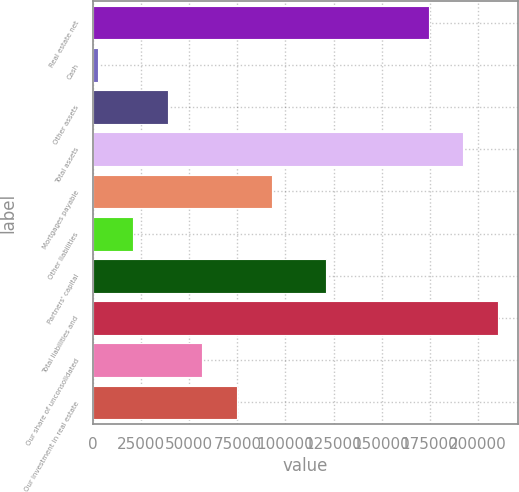Convert chart to OTSL. <chart><loc_0><loc_0><loc_500><loc_500><bar_chart><fcel>Real estate net<fcel>Cash<fcel>Other assets<fcel>Total assets<fcel>Mortgages payable<fcel>Other liabilities<fcel>Partners' capital<fcel>Total liabilities and<fcel>Our share of unconsolidated<fcel>Our investment in real estate<nl><fcel>174509<fcel>2735<fcel>38744<fcel>192514<fcel>92757.5<fcel>20739.5<fcel>120854<fcel>210518<fcel>56748.5<fcel>74753<nl></chart> 